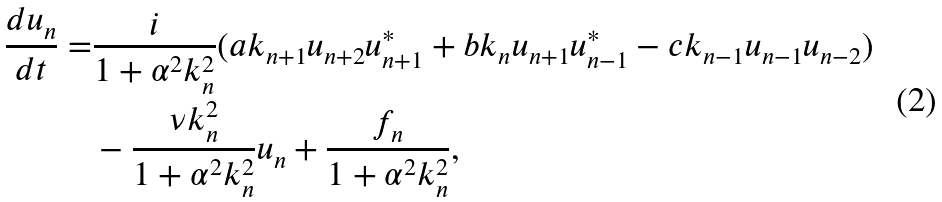Convert formula to latex. <formula><loc_0><loc_0><loc_500><loc_500>\frac { d u _ { n } } { d t } = & \frac { i } { 1 + \alpha ^ { 2 } k _ { n } ^ { 2 } } ( a k _ { n + 1 } u _ { n + 2 } u _ { n + 1 } ^ { * } + b k _ { n } u _ { n + 1 } u _ { n - 1 } ^ { * } - c k _ { n - 1 } u _ { n - 1 } u _ { n - 2 } ) \\ & - \frac { \nu k _ { n } ^ { 2 } } { 1 + \alpha ^ { 2 } k _ { n } ^ { 2 } } u _ { n } + \frac { f _ { n } } { 1 + \alpha ^ { 2 } k _ { n } ^ { 2 } } ,</formula> 